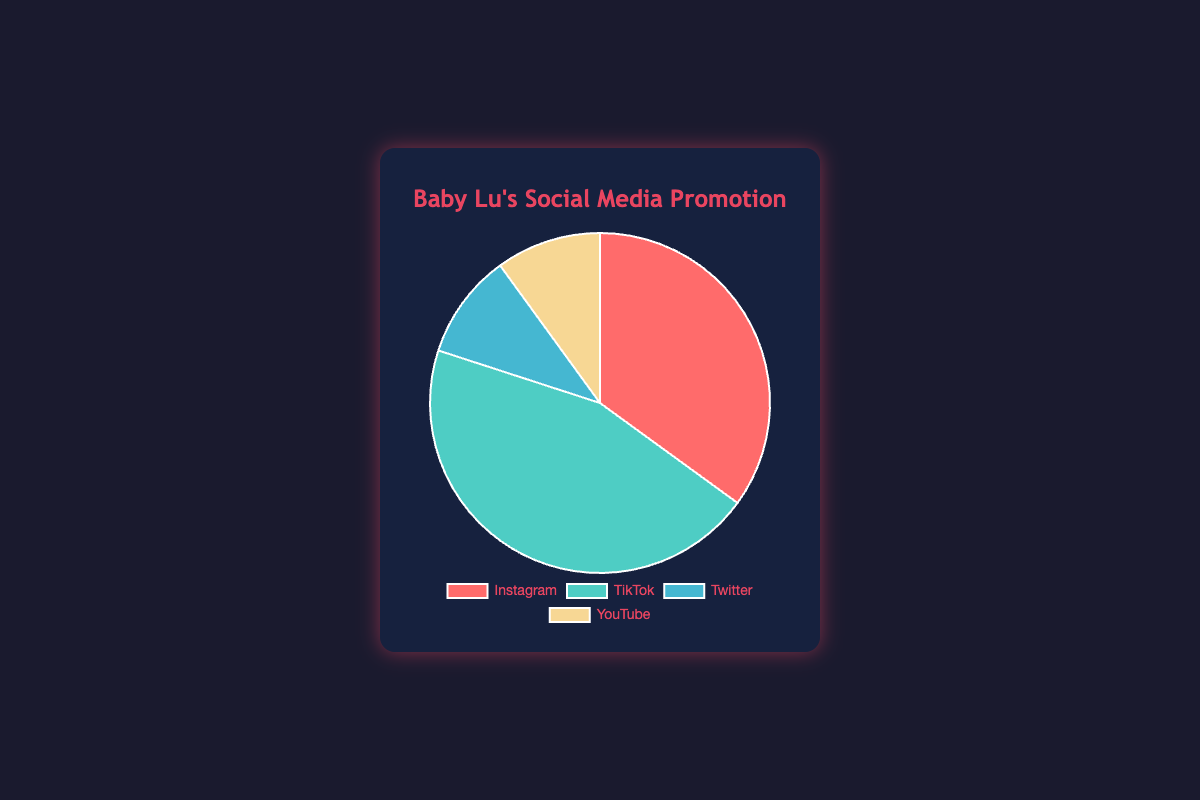What's the most popular social media platform for promoting Baby Lu’s music? We can observe that TikTok has the largest slice of the pie chart, occupying 45%. Therefore, TikTok is the most popular platform.
Answer: TikTok Which social media platforms have an equal share of promotion? By looking at the pie chart, Twitter and YouTube each have a slice representing 10%. Thus, they have an equal share.
Answer: Twitter and YouTube What is the difference in promotional share between TikTok and Instagram? TikTok has 45%, and Instagram has 35%. By subtracting Instagram's percentage from TikTok’s (45% - 35%) we find the difference is 10%.
Answer: 10% Sum the combined percentage shares of Twitter and YouTube. Twitter has 10% and YouTube has 10%. Adding them together (10% + 10%) totals 20%.
Answer: 20% Which platform shows the second highest percentage for promoting Baby Lu’s music? The pie chart clearly shows that Instagram has the second largest slice at 35%, following TikTok. Thus, Instagram is second highest.
Answer: Instagram Is the share of TikTok greater than the combined share of Twitter and YouTube? By how much? TikTok's share is 45%, and the combined share of Twitter and YouTube is 20%. Subtract the smaller total from TikTok's share (45% - 20%) to get 25%.
Answer: Yes, by 25% Which segment of the pie chart is depicted in green? The green segment represents TikTok, as can be seen from the chart's color legends.
Answer: TikTok Which has a smaller promotional share, Instagram or the combined share of Twitter and YouTube? Instagram has a 35% share; Twitter and YouTube together combine for 20%. Since 20% is smaller than 35%, the combined share of Twitter and YouTube is smaller.
Answer: Combined share of Twitter and YouTube 